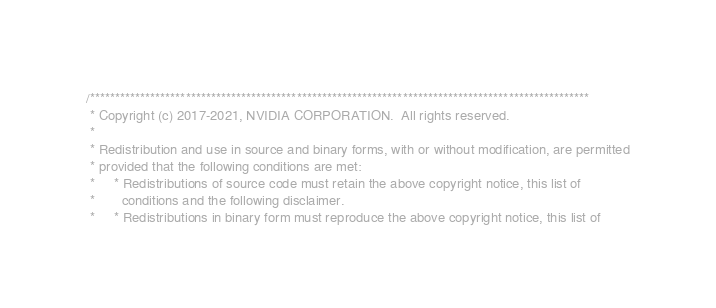Convert code to text. <code><loc_0><loc_0><loc_500><loc_500><_Cuda_>/***************************************************************************************************
 * Copyright (c) 2017-2021, NVIDIA CORPORATION.  All rights reserved.
 *
 * Redistribution and use in source and binary forms, with or without modification, are permitted
 * provided that the following conditions are met:
 *     * Redistributions of source code must retain the above copyright notice, this list of
 *       conditions and the following disclaimer.
 *     * Redistributions in binary form must reproduce the above copyright notice, this list of</code> 